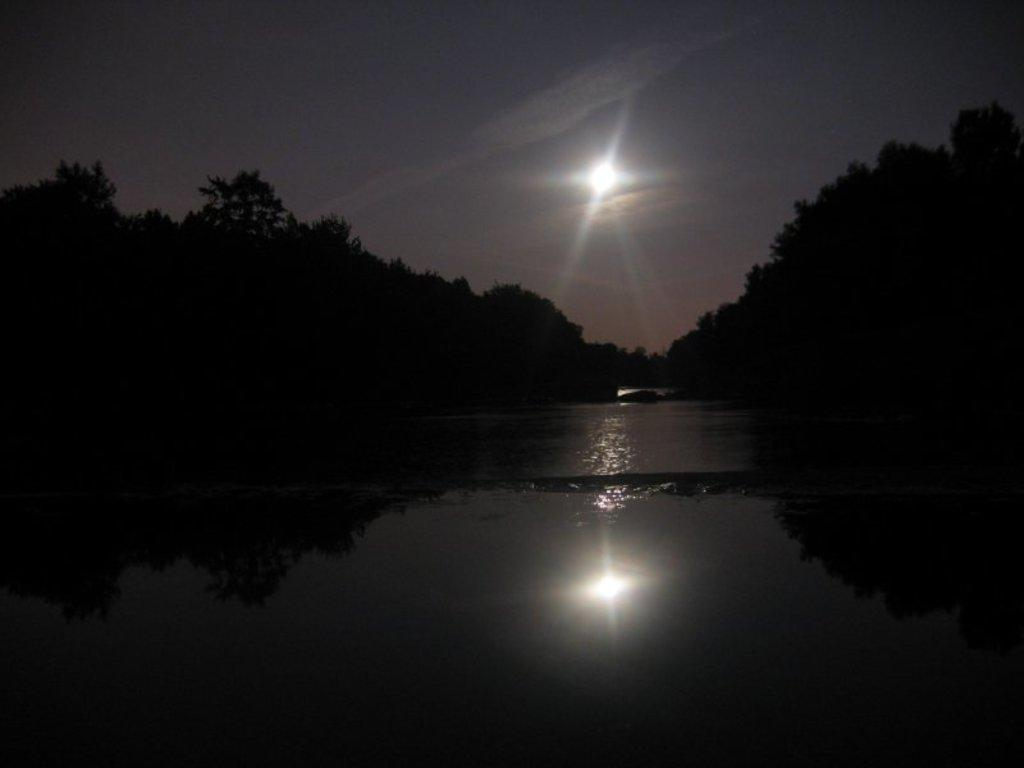What celestial body can be seen in the sky in the image? The moon is visible in the sky in the image. What type of vegetation is present on both sides of the image? There are trees on both sides of the image. What natural element is visible in the image? Water is visible in the image. Can you tell me what type of quill the stranger is using to write a letter to their friend in the image? There is no stranger or quill present in the image, and therefore no such activity can be observed. 